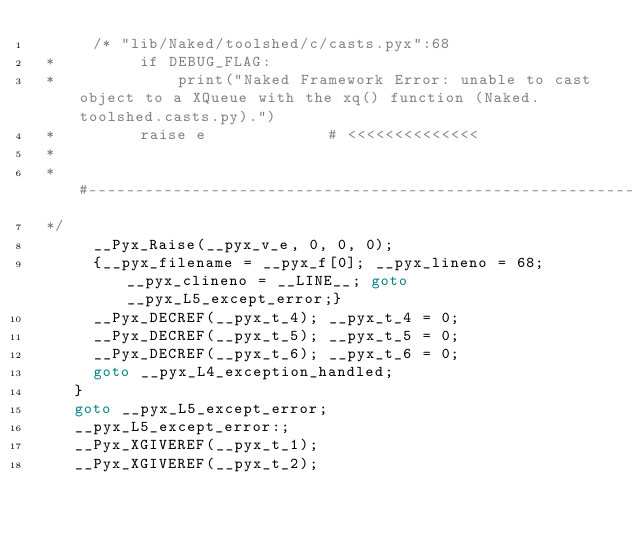Convert code to text. <code><loc_0><loc_0><loc_500><loc_500><_C_>      /* "lib/Naked/toolshed/c/casts.pyx":68
 *         if DEBUG_FLAG:
 *             print("Naked Framework Error: unable to cast object to a XQueue with the xq() function (Naked.toolshed.casts.py).")
 *         raise e             # <<<<<<<<<<<<<<
 * 
 * #------------------------------------------------------------------------------
 */
      __Pyx_Raise(__pyx_v_e, 0, 0, 0);
      {__pyx_filename = __pyx_f[0]; __pyx_lineno = 68; __pyx_clineno = __LINE__; goto __pyx_L5_except_error;}
      __Pyx_DECREF(__pyx_t_4); __pyx_t_4 = 0;
      __Pyx_DECREF(__pyx_t_5); __pyx_t_5 = 0;
      __Pyx_DECREF(__pyx_t_6); __pyx_t_6 = 0;
      goto __pyx_L4_exception_handled;
    }
    goto __pyx_L5_except_error;
    __pyx_L5_except_error:;
    __Pyx_XGIVEREF(__pyx_t_1);
    __Pyx_XGIVEREF(__pyx_t_2);</code> 